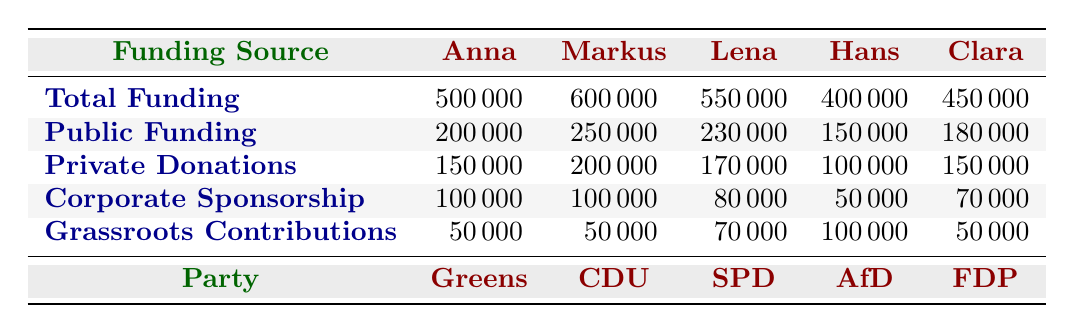What is the total funding for Anna Schmidt? According to the table, the row for Anna Schmidt shows a total funding value of 500000.
Answer: 500000 Which candidate received the highest public funding? Examining the public funding row, Markus Müller has the highest figure at 250000.
Answer: Markus Müller What is the total amount of private donations for Lena Fischer? The row for Lena Fischer indicates that her private donations total 170000.
Answer: 170000 Which political party received the least total funding? The total funding values show that Hans Müller from the AfD has the lowest total funding of 400000 among the candidates.
Answer: AfD If we add the grassroots contributions for all candidates, what is the total? Adding up all grassroots contributions: 50000 (Anna) + 50000 (Markus) + 70000 (Lena) + 100000 (Hans) + 50000 (Clara) equals 350000.
Answer: 350000 Did Clara Neumann receive more corporate sponsorship than Lena Fischer? Clara Neumann's corporate sponsorship is 70000, while Lena Fischer's is 80000. Thus, Clara received less.
Answer: No What is the average total funding for all candidates? Summing the total funding for all candidates gives 500000 + 600000 + 550000 + 400000 + 450000 = 2500000. Dividing by the number of candidates (5) results in an average of 500000.
Answer: 500000 Does Anna Schmidt have more public funding than total grassroots contributions? Anna Schmidt's public funding is 200000, while her grassroots contributions are 50000. Therefore, her public funding is more.
Answer: Yes Which candidate's funding comes entirely from public funding, private donations, corporate sponsorship, and grassroots contribution? No candidate's funding is entirely from just one source; all candidates have mixes of each type of funding.
Answer: No 